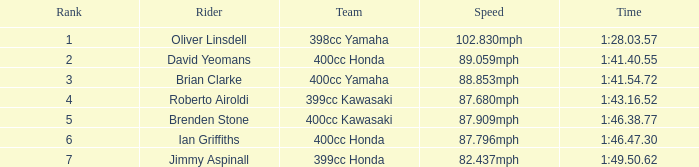What position does the rider with a time of 1:41.40.55 hold? 2.0. 